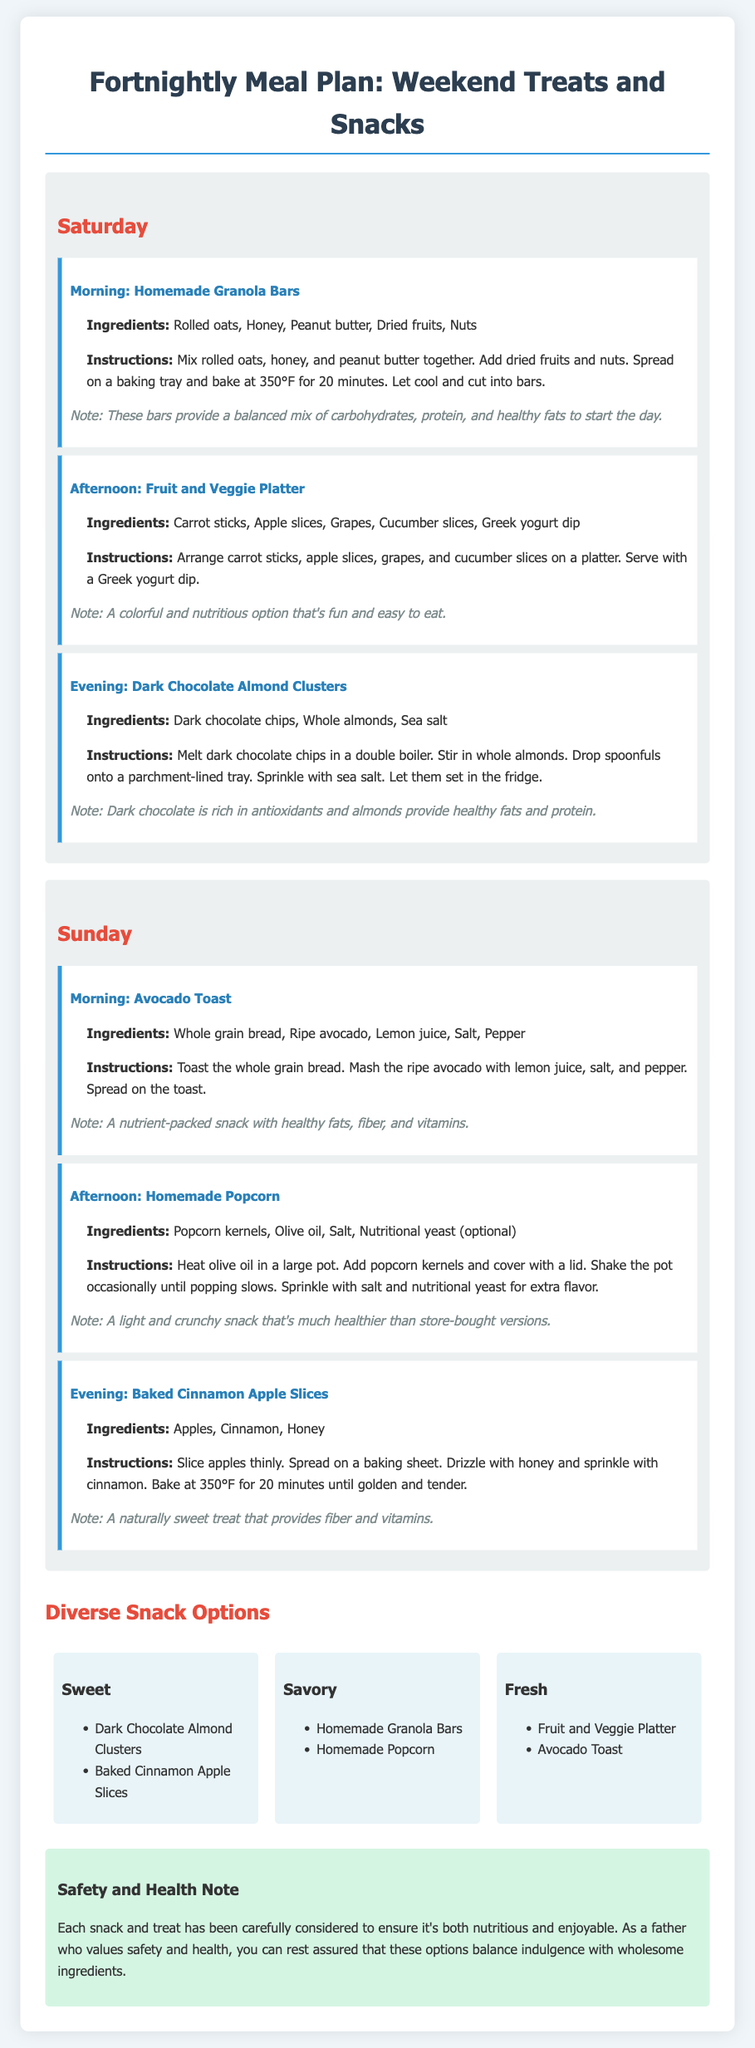What snacks are included for Saturday morning? The document lists "Homemade Granola Bars" as the snack for Saturday morning.
Answer: Homemade Granola Bars What is the main ingredient in Dark Chocolate Almond Clusters? The primary ingredient mentioned for Dark Chocolate Almond Clusters is "Dark chocolate chips."
Answer: Dark chocolate chips How long should the baked cinnamon apple slices be baked? The document states that the apple slices should be baked for 20 minutes.
Answer: 20 minutes Which type of snack is the Fruit and Veggie Platter categorized under? The Fruit and Veggie Platter is included in the "Fresh" snack options.
Answer: Fresh What healthy component do the homemade granola bars provide? The document mentions that the homemade granola bars provide a mix of carbohydrates, protein, and healthy fats.
Answer: Carbohydrates, protein, and healthy fats How many types of snacks are listed in the Diverse Snack Options section? There are three types of snacks noted: Sweet, Savory, and Fresh.
Answer: Three What is a suggested dip for the Fruit and Veggie Platter? The document specifies "Greek yogurt dip" as the suggested dip.
Answer: Greek yogurt dip What healthy ingredient is combined with whole almonds in the Dark Chocolate Almond Clusters? The document indicates that "Sea salt" is combined with whole almonds.
Answer: Sea salt 